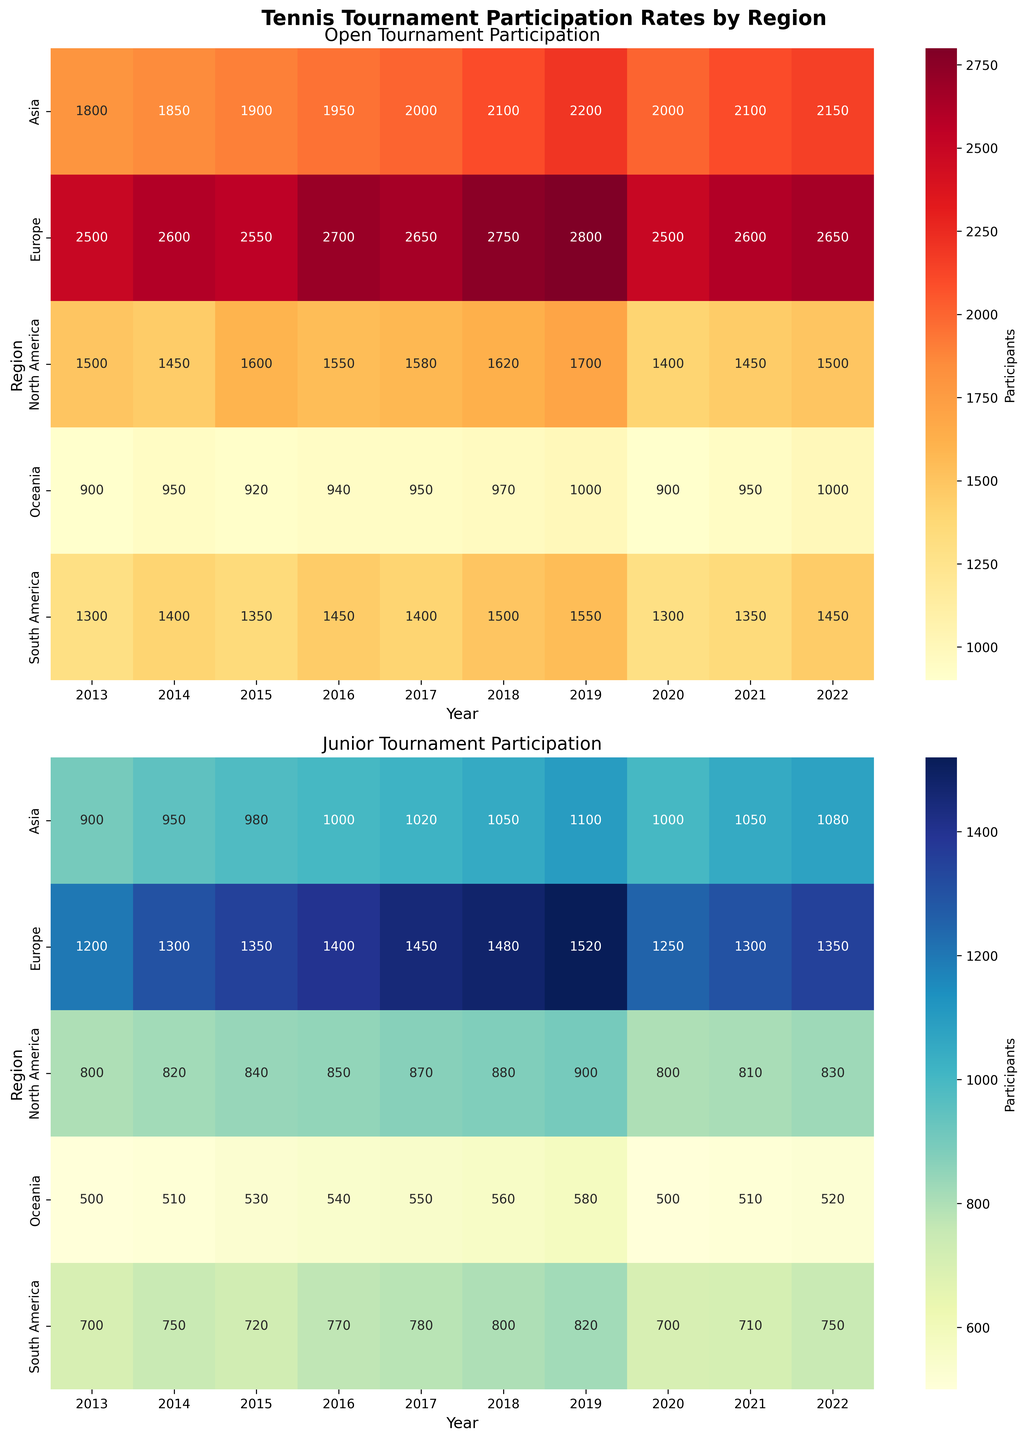How does the participation rate trend for North America in Open Tournaments from 2016 to 2020 look? In the Open Tournament Participation heatmap for North America from 2016 to 2020, note the colors and numbers in each box for those years. Participation starts at 1550 in 2016 and fluctuates before dropping significantly to 1400 in 2020, indicating a decrease by the end of the period.
Answer: Decreasing trend Which region had the highest Junior Tournament participation in 2017? Look at the Junior Tournament Participation heatmap and identify the region with the darkest shade and highest number in 2017. Europe shows 1450, which is the highest among regions.
Answer: Europe Compare the Open Tournament participation between Asia and South America in 2018. Which had more participants? Observe the Open Tournament Participation heatmap for 2018. Asia has 2100 participants while South America has 1500 participants. Asia has more participants.
Answer: Asia What is the average Junior Tournament participation for Europe from 2017 to 2019? Locate the numbers in the Junior Participation heatmap for Europe from 2017 to 2019 (1450, 1480, 1520). Sum these values (1450 + 1480 + 1520 = 4450) then divide by 3 years to get the average (4450/3 = 1483.33).
Answer: 1483.33 Has the Open Tournament participation in Oceania increased or decreased from 2013 to 2022? Check the trend visible in the Open Tournament Participation heatmap for Oceania from 2013 (900) to 2022 (1000). There's an overall increase, despite some fluctuations.
Answer: Increased Which two regions have the closest Junior Tournament participation numbers in 2021? Observe the Junior Participation heatmap for 2021. North America has 810 and South America has 710. The closest numbers are North America (810) and South America (710), a difference of 100.
Answer: North America and South America What is the difference in Open Tournament participation between Europe and North America in 2019? Find the 2019 values in the Open Tournament Participation heatmap: Europe (2800), North America (1700). Subtract North America's number from Europe's (2800 - 1700 = 1100).
Answer: 1100 Which year had the highest Junior Tournament participation in Asia? Look at Asia's row in the Junior Participation heatmap and identify the year with the darkest shade and highest number. The highest is 2019 with 1100 participants.
Answer: 2019 Which region had the least increase in Open Tournament participation from 2013 to 2014? Identify the change in numbers from 2013 to 2014 in the Open Tournament Participation heatmap for all regions. Oceania shows an increase from 900 to 950, which is a 50 participants increase, the least among all regions.
Answer: Oceania 